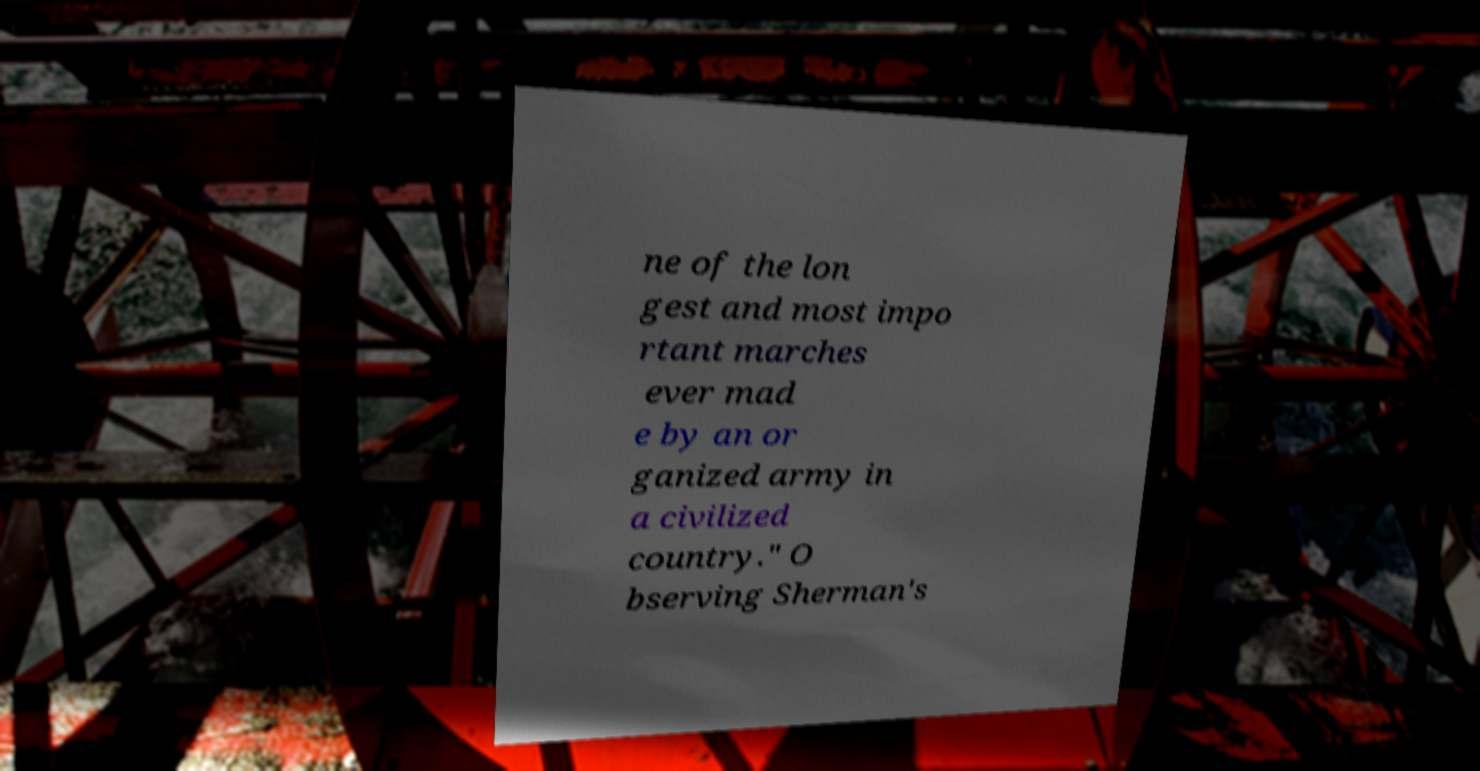Please read and relay the text visible in this image. What does it say? ne of the lon gest and most impo rtant marches ever mad e by an or ganized army in a civilized country." O bserving Sherman's 